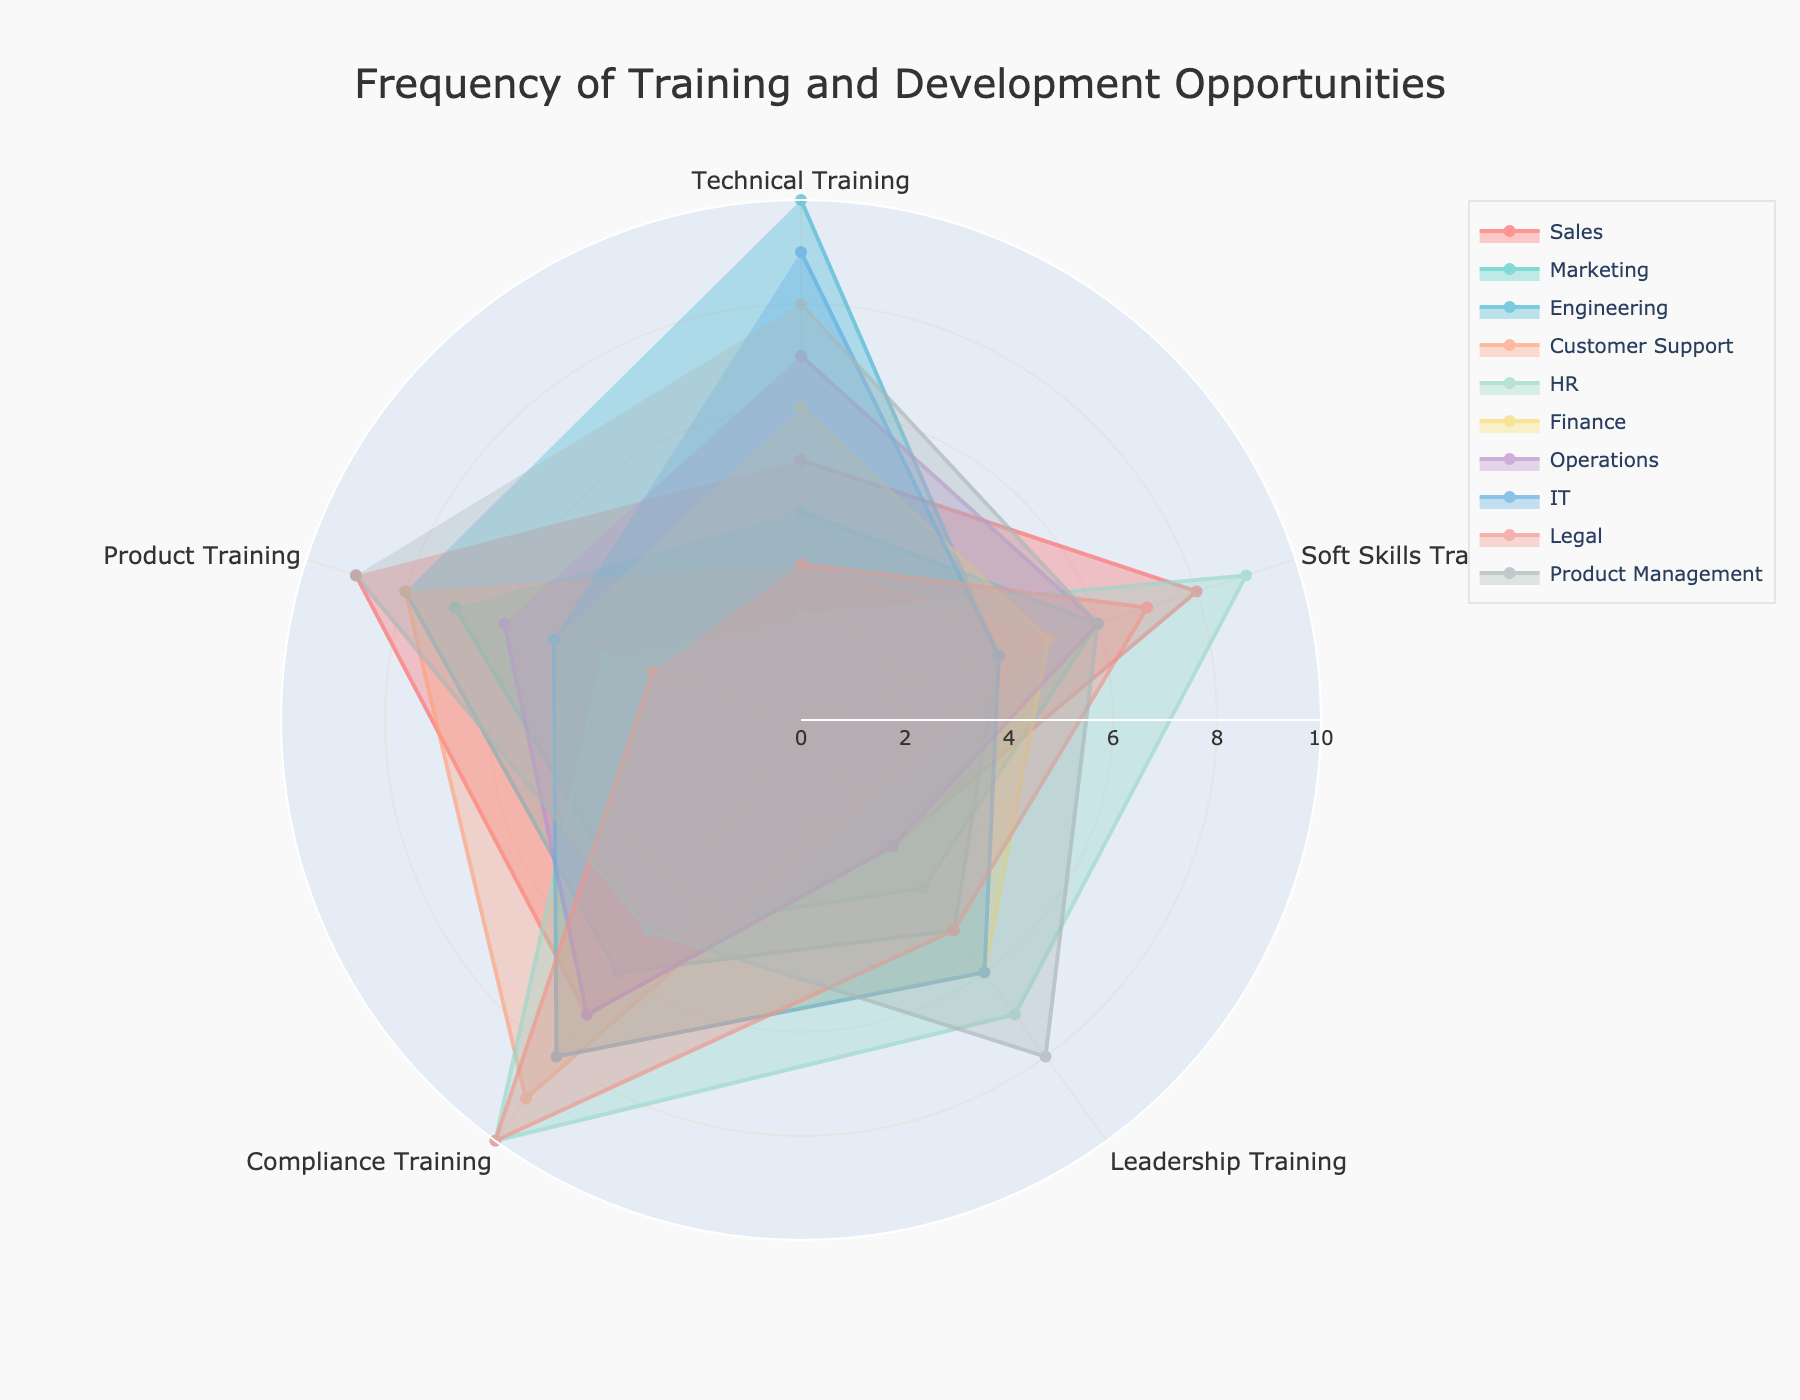what is the highest frequency of technical training for any team? Look for the longest line segment in the technical training axis. The engineering team has the longest line towards technical training, reaching the maximum value of 10.
Answer: 10 Which team has the most balanced training opportunities across all categories? A balanced team should have a shape close to a regular polygon. Product Management has relatively equal values in all categories, leading to a more regular, balanced shape.
Answer: Product Management Which two teams have the highest frequency of compliance training? Look for the longest line segments in the compliance training axis. HR and Legal have the longest line segments indicating the highest frequencies of 10 each.
Answer: HR, Legal What is the average frequency of leadership training for the Finance and IT teams? Sum the leadership training values for the Finance (6) and IT (6) teams and divide by 2. The average is (6 + 6) / 2 = 6.
Answer: 6 Are there any teams with a compliance training frequency of 7? Which one(s)? Look at the line segment lengths on the compliance training axis and identify any team at the value of 7. The Sales and Operations teams both have a compliance training frequency of 7.
Answer: Sales, Operations Which team has the least amount of soft skills training? Look for the shortest line segment in the soft skills training axis. The Engineering team has the shortest line segment with a value of 4.
Answer: Engineering How does the frequency of product training in the Marketing team compare to the Sales team? Compare the lengths of the line segments on the product training axis for both teams. The Sales team has a value of 9 whereas Marketing has a value of 7, so Sales has higher product training frequency.
Answer: Sales has higher What is the total frequency of all training categories for the Legal team? Sum the frequencies of all training categories for the Legal team. The total is 3 + 7 + 5 + 10 + 3 = 28.
Answer: 28 